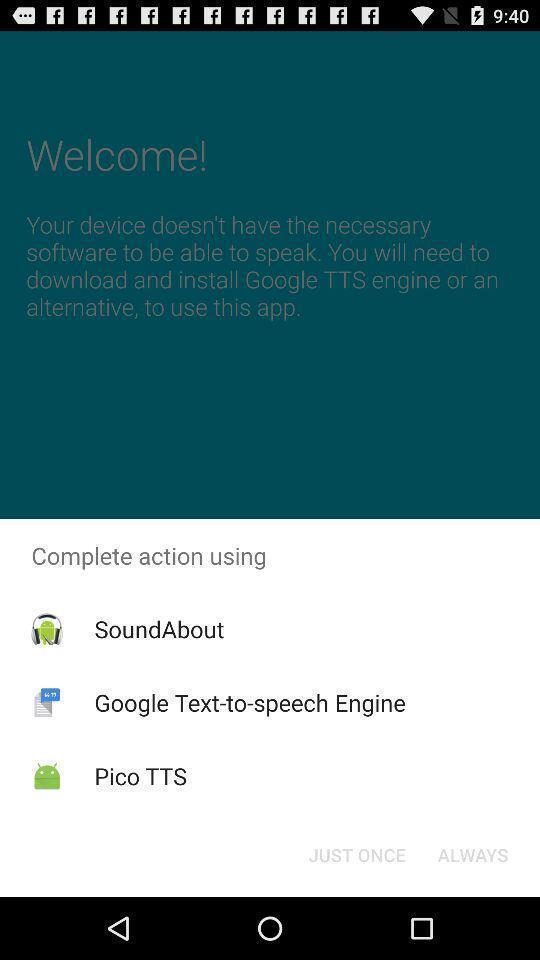Describe the key features of this screenshot. Pop-up showing different options to complete action. 